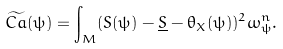Convert formula to latex. <formula><loc_0><loc_0><loc_500><loc_500>\widetilde { C a } ( \psi ) = \int _ { M } ( S ( \psi ) - \underline { S } - \theta _ { X } ( \psi ) ) ^ { 2 } \omega _ { \psi } ^ { n } .</formula> 